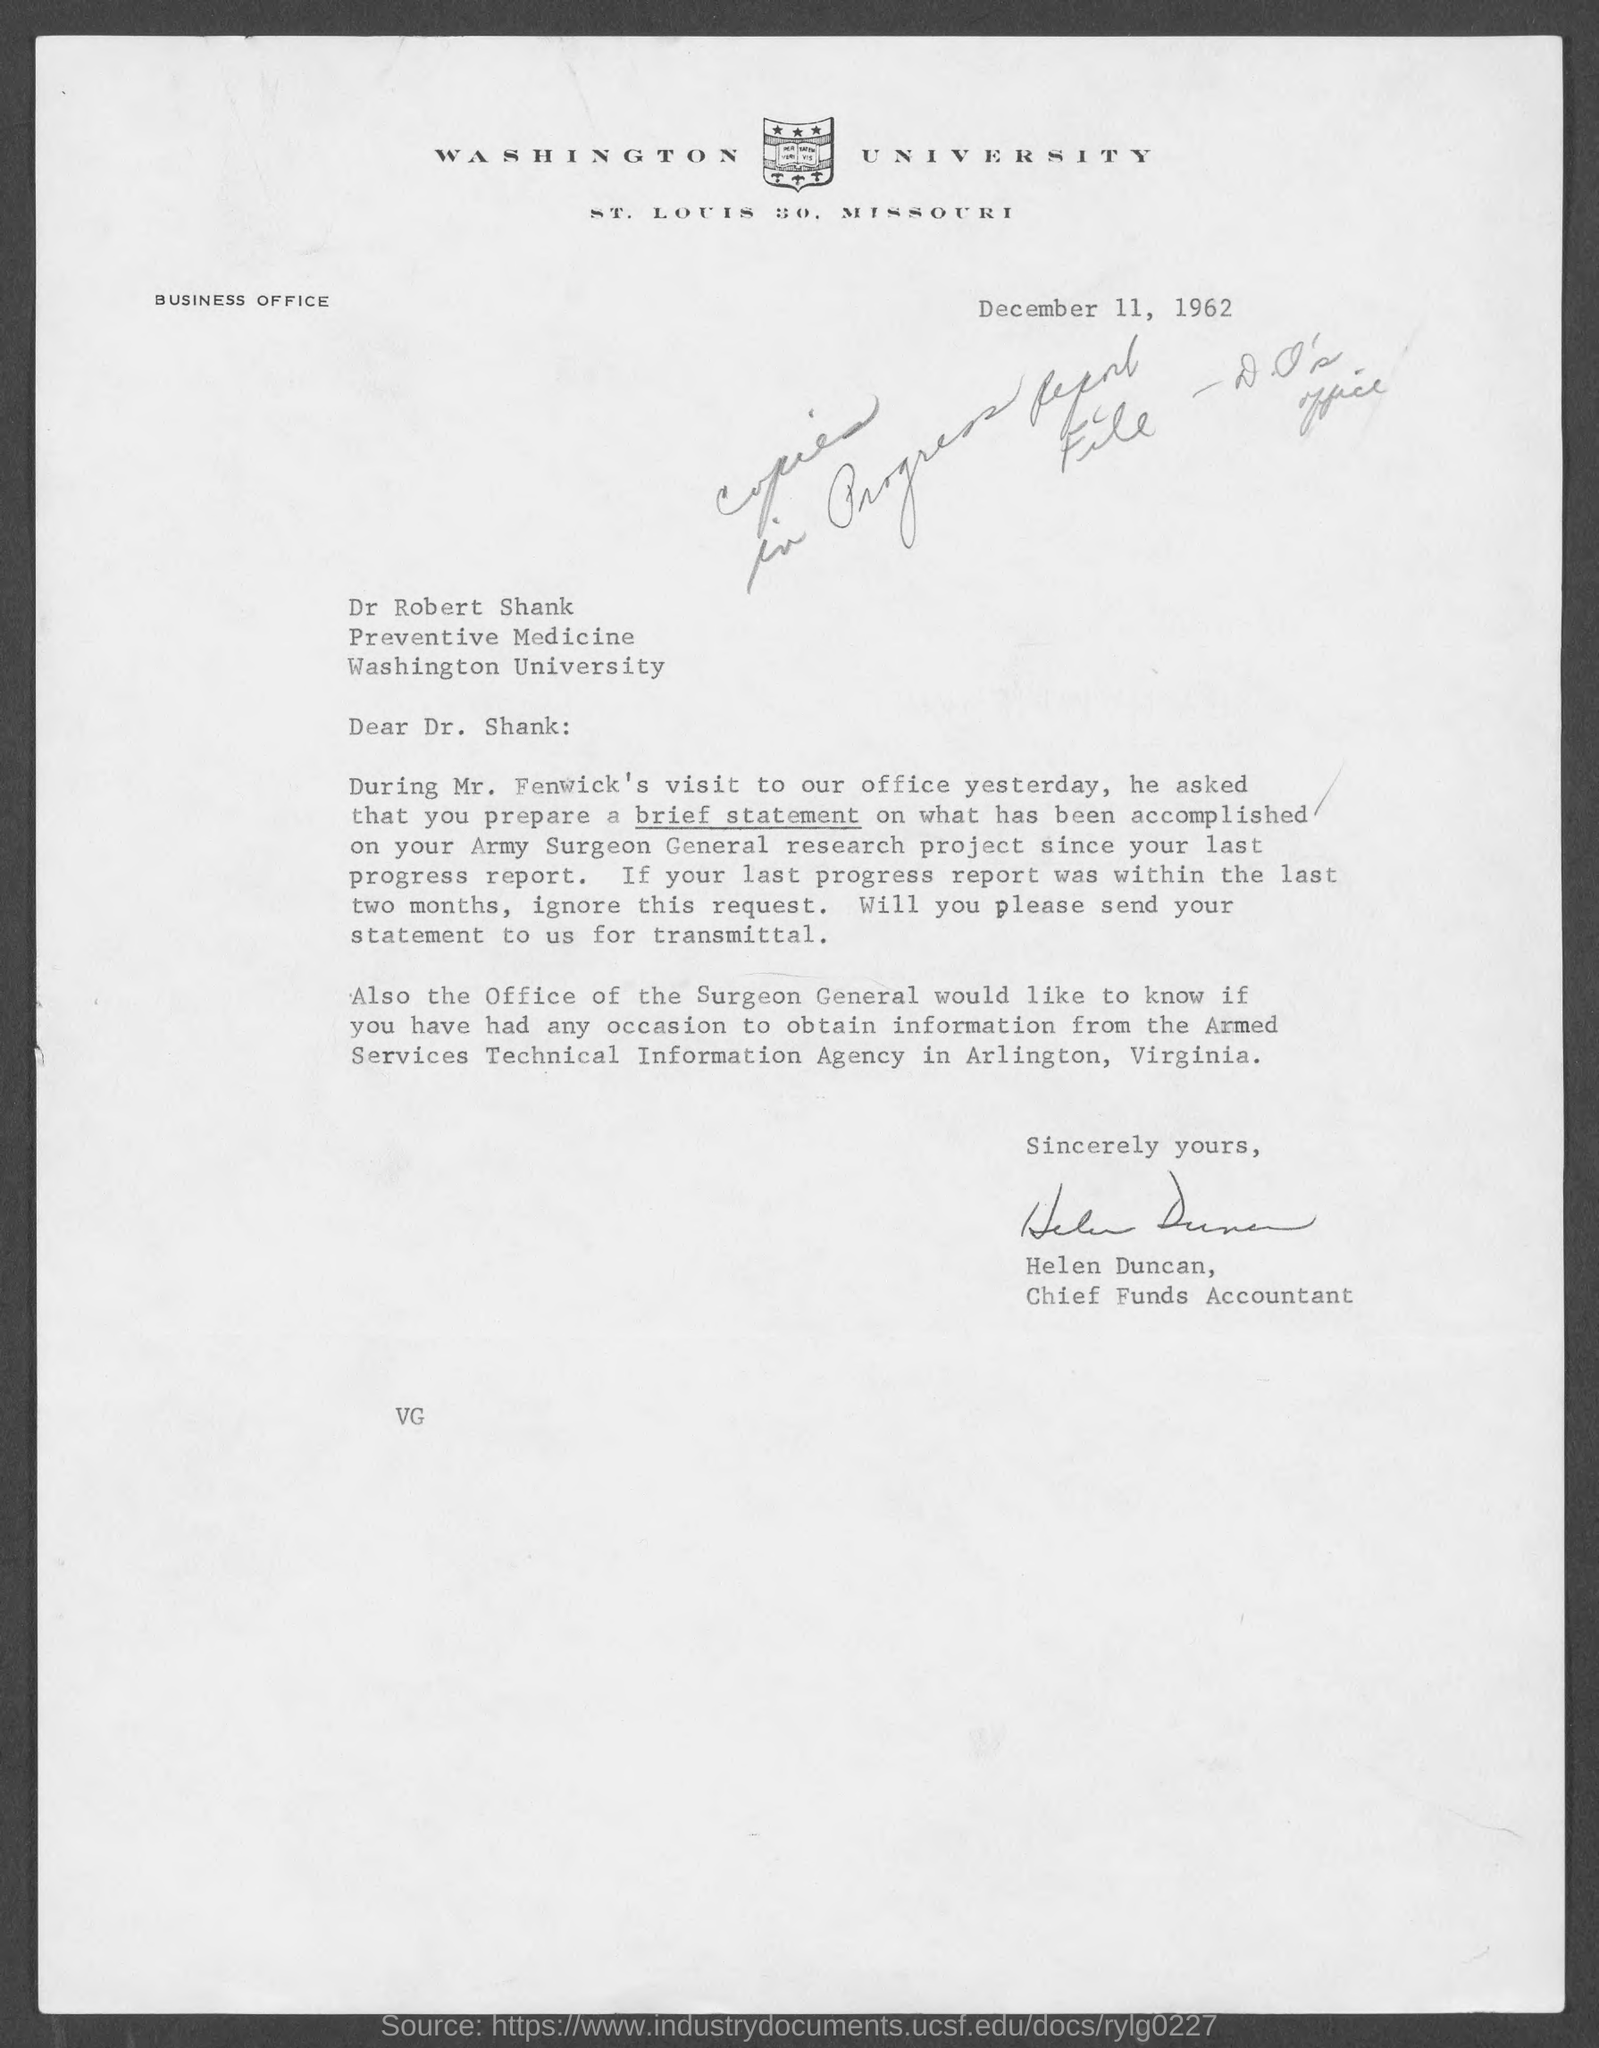Mention a couple of crucial points in this snapshot. The document was dated December 11, 1962. The sender is Helen Duncan. Helen Duncan is the Chief Funds Accountant. 